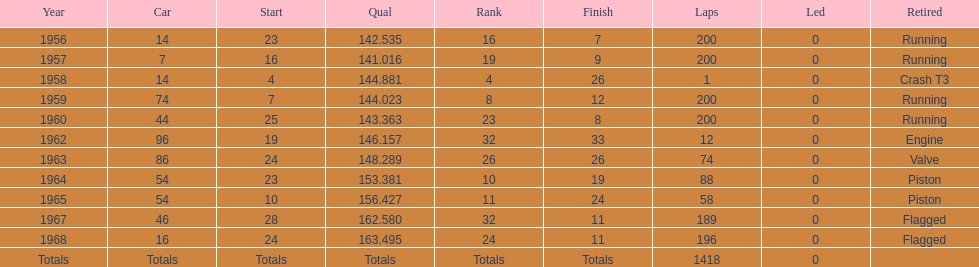Which year did he own a car with the same number as in 1964? 1965. 